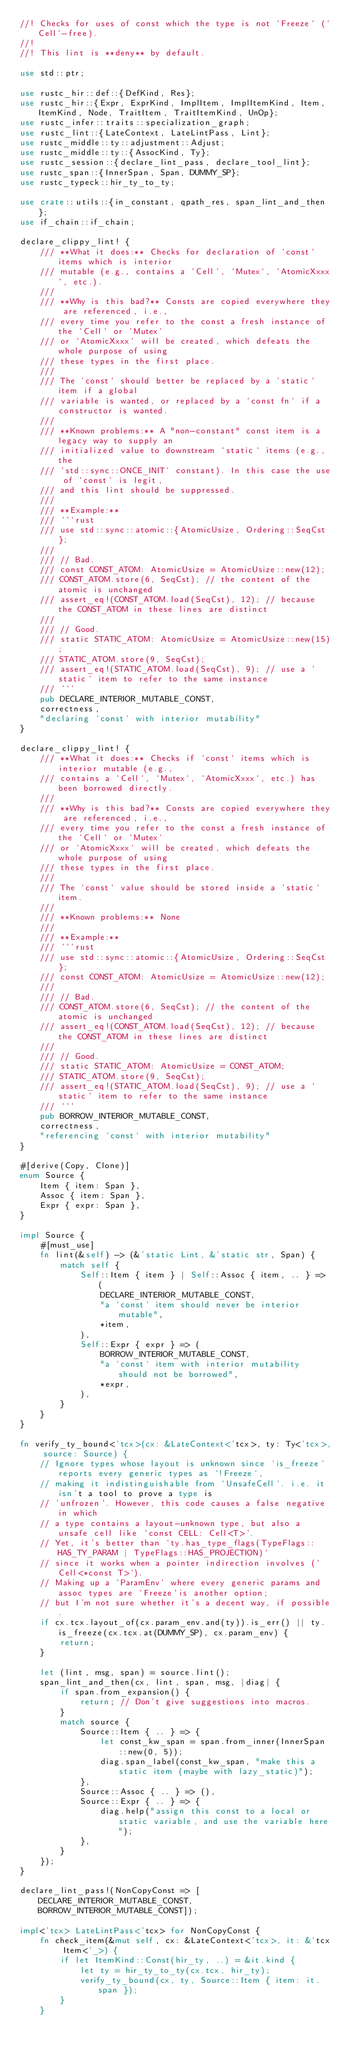<code> <loc_0><loc_0><loc_500><loc_500><_Rust_>//! Checks for uses of const which the type is not `Freeze` (`Cell`-free).
//!
//! This lint is **deny** by default.

use std::ptr;

use rustc_hir::def::{DefKind, Res};
use rustc_hir::{Expr, ExprKind, ImplItem, ImplItemKind, Item, ItemKind, Node, TraitItem, TraitItemKind, UnOp};
use rustc_infer::traits::specialization_graph;
use rustc_lint::{LateContext, LateLintPass, Lint};
use rustc_middle::ty::adjustment::Adjust;
use rustc_middle::ty::{AssocKind, Ty};
use rustc_session::{declare_lint_pass, declare_tool_lint};
use rustc_span::{InnerSpan, Span, DUMMY_SP};
use rustc_typeck::hir_ty_to_ty;

use crate::utils::{in_constant, qpath_res, span_lint_and_then};
use if_chain::if_chain;

declare_clippy_lint! {
    /// **What it does:** Checks for declaration of `const` items which is interior
    /// mutable (e.g., contains a `Cell`, `Mutex`, `AtomicXxxx`, etc.).
    ///
    /// **Why is this bad?** Consts are copied everywhere they are referenced, i.e.,
    /// every time you refer to the const a fresh instance of the `Cell` or `Mutex`
    /// or `AtomicXxxx` will be created, which defeats the whole purpose of using
    /// these types in the first place.
    ///
    /// The `const` should better be replaced by a `static` item if a global
    /// variable is wanted, or replaced by a `const fn` if a constructor is wanted.
    ///
    /// **Known problems:** A "non-constant" const item is a legacy way to supply an
    /// initialized value to downstream `static` items (e.g., the
    /// `std::sync::ONCE_INIT` constant). In this case the use of `const` is legit,
    /// and this lint should be suppressed.
    ///
    /// **Example:**
    /// ```rust
    /// use std::sync::atomic::{AtomicUsize, Ordering::SeqCst};
    ///
    /// // Bad.
    /// const CONST_ATOM: AtomicUsize = AtomicUsize::new(12);
    /// CONST_ATOM.store(6, SeqCst); // the content of the atomic is unchanged
    /// assert_eq!(CONST_ATOM.load(SeqCst), 12); // because the CONST_ATOM in these lines are distinct
    ///
    /// // Good.
    /// static STATIC_ATOM: AtomicUsize = AtomicUsize::new(15);
    /// STATIC_ATOM.store(9, SeqCst);
    /// assert_eq!(STATIC_ATOM.load(SeqCst), 9); // use a `static` item to refer to the same instance
    /// ```
    pub DECLARE_INTERIOR_MUTABLE_CONST,
    correctness,
    "declaring `const` with interior mutability"
}

declare_clippy_lint! {
    /// **What it does:** Checks if `const` items which is interior mutable (e.g.,
    /// contains a `Cell`, `Mutex`, `AtomicXxxx`, etc.) has been borrowed directly.
    ///
    /// **Why is this bad?** Consts are copied everywhere they are referenced, i.e.,
    /// every time you refer to the const a fresh instance of the `Cell` or `Mutex`
    /// or `AtomicXxxx` will be created, which defeats the whole purpose of using
    /// these types in the first place.
    ///
    /// The `const` value should be stored inside a `static` item.
    ///
    /// **Known problems:** None
    ///
    /// **Example:**
    /// ```rust
    /// use std::sync::atomic::{AtomicUsize, Ordering::SeqCst};
    /// const CONST_ATOM: AtomicUsize = AtomicUsize::new(12);
    ///
    /// // Bad.
    /// CONST_ATOM.store(6, SeqCst); // the content of the atomic is unchanged
    /// assert_eq!(CONST_ATOM.load(SeqCst), 12); // because the CONST_ATOM in these lines are distinct
    ///
    /// // Good.
    /// static STATIC_ATOM: AtomicUsize = CONST_ATOM;
    /// STATIC_ATOM.store(9, SeqCst);
    /// assert_eq!(STATIC_ATOM.load(SeqCst), 9); // use a `static` item to refer to the same instance
    /// ```
    pub BORROW_INTERIOR_MUTABLE_CONST,
    correctness,
    "referencing `const` with interior mutability"
}

#[derive(Copy, Clone)]
enum Source {
    Item { item: Span },
    Assoc { item: Span },
    Expr { expr: Span },
}

impl Source {
    #[must_use]
    fn lint(&self) -> (&'static Lint, &'static str, Span) {
        match self {
            Self::Item { item } | Self::Assoc { item, .. } => (
                DECLARE_INTERIOR_MUTABLE_CONST,
                "a `const` item should never be interior mutable",
                *item,
            ),
            Self::Expr { expr } => (
                BORROW_INTERIOR_MUTABLE_CONST,
                "a `const` item with interior mutability should not be borrowed",
                *expr,
            ),
        }
    }
}

fn verify_ty_bound<'tcx>(cx: &LateContext<'tcx>, ty: Ty<'tcx>, source: Source) {
    // Ignore types whose layout is unknown since `is_freeze` reports every generic types as `!Freeze`,
    // making it indistinguishable from `UnsafeCell`. i.e. it isn't a tool to prove a type is
    // 'unfrozen'. However, this code causes a false negative in which
    // a type contains a layout-unknown type, but also a unsafe cell like `const CELL: Cell<T>`.
    // Yet, it's better than `ty.has_type_flags(TypeFlags::HAS_TY_PARAM | TypeFlags::HAS_PROJECTION)`
    // since it works when a pointer indirection involves (`Cell<*const T>`).
    // Making up a `ParamEnv` where every generic params and assoc types are `Freeze`is another option;
    // but I'm not sure whether it's a decent way, if possible.
    if cx.tcx.layout_of(cx.param_env.and(ty)).is_err() || ty.is_freeze(cx.tcx.at(DUMMY_SP), cx.param_env) {
        return;
    }

    let (lint, msg, span) = source.lint();
    span_lint_and_then(cx, lint, span, msg, |diag| {
        if span.from_expansion() {
            return; // Don't give suggestions into macros.
        }
        match source {
            Source::Item { .. } => {
                let const_kw_span = span.from_inner(InnerSpan::new(0, 5));
                diag.span_label(const_kw_span, "make this a static item (maybe with lazy_static)");
            },
            Source::Assoc { .. } => (),
            Source::Expr { .. } => {
                diag.help("assign this const to a local or static variable, and use the variable here");
            },
        }
    });
}

declare_lint_pass!(NonCopyConst => [DECLARE_INTERIOR_MUTABLE_CONST, BORROW_INTERIOR_MUTABLE_CONST]);

impl<'tcx> LateLintPass<'tcx> for NonCopyConst {
    fn check_item(&mut self, cx: &LateContext<'tcx>, it: &'tcx Item<'_>) {
        if let ItemKind::Const(hir_ty, ..) = &it.kind {
            let ty = hir_ty_to_ty(cx.tcx, hir_ty);
            verify_ty_bound(cx, ty, Source::Item { item: it.span });
        }
    }
</code> 